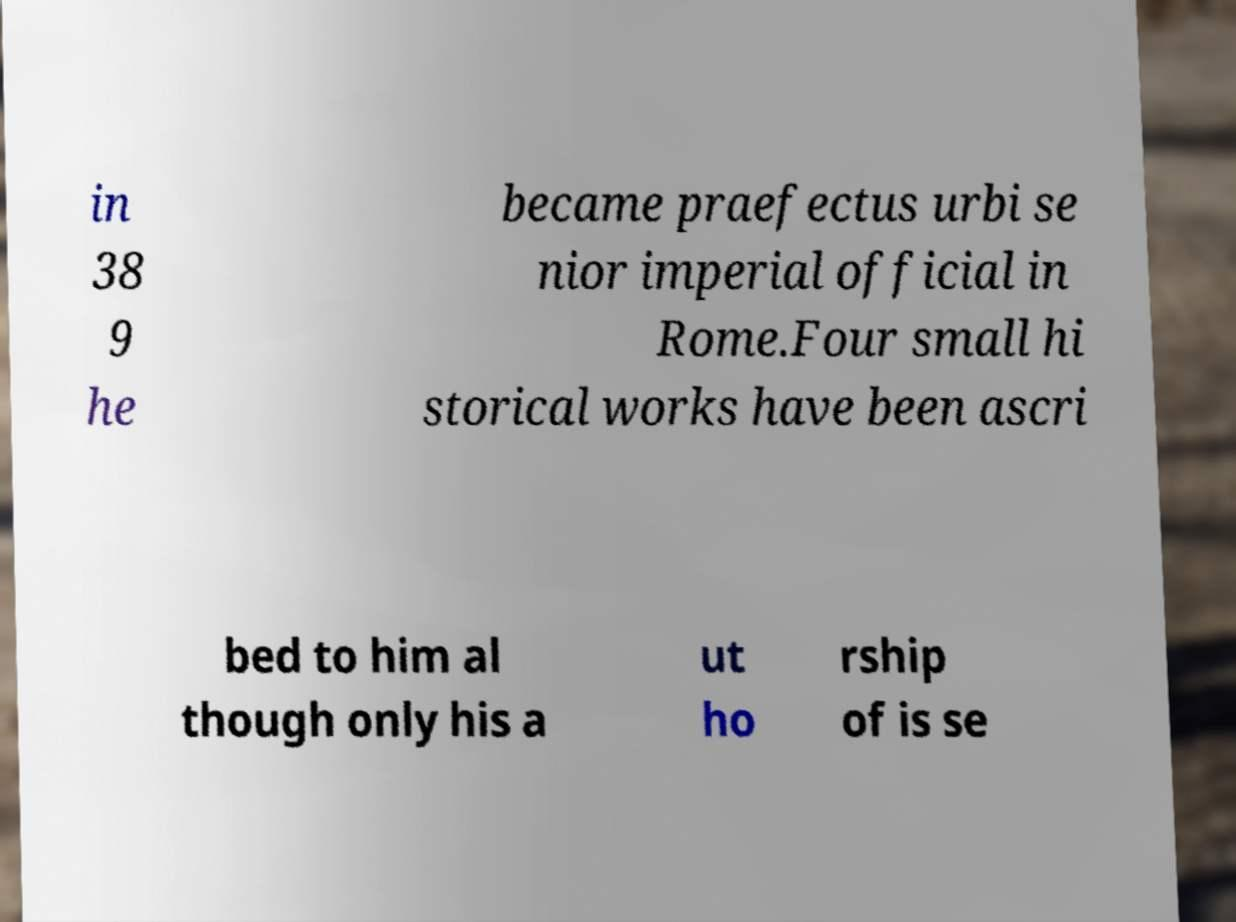For documentation purposes, I need the text within this image transcribed. Could you provide that? in 38 9 he became praefectus urbi se nior imperial official in Rome.Four small hi storical works have been ascri bed to him al though only his a ut ho rship of is se 